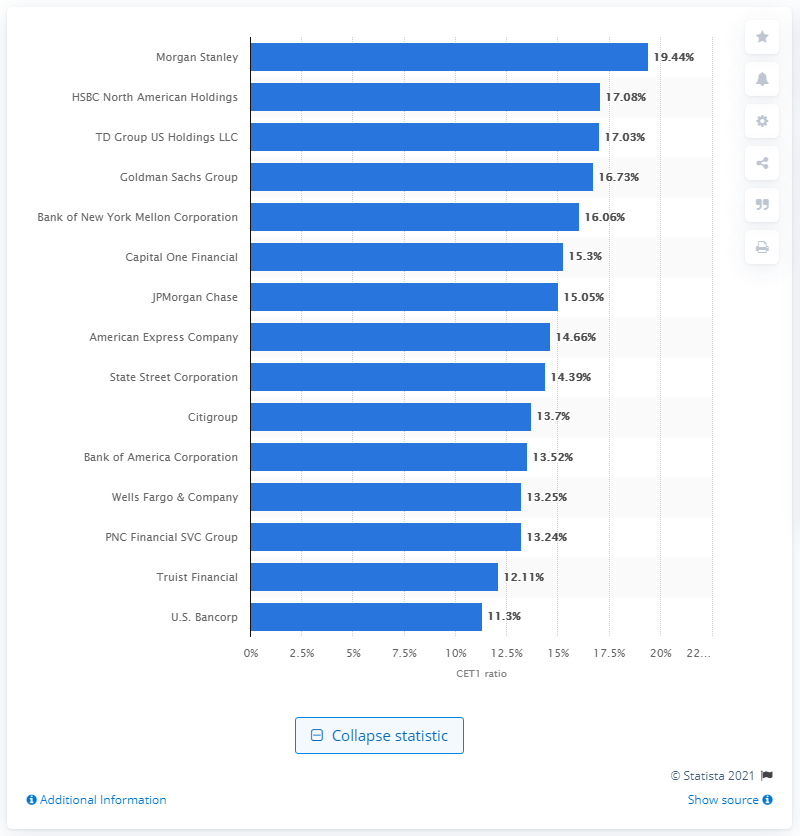Highlight a few significant elements in this photo. Morgan Stanley's CET1 ratio was 19.44%. In the fourth quarter of 2020, Morgan Stanley had the highest common equity tier 1 capital ratio among banks in the United States. JPMorgan Chase is the largest bank in the United States. 